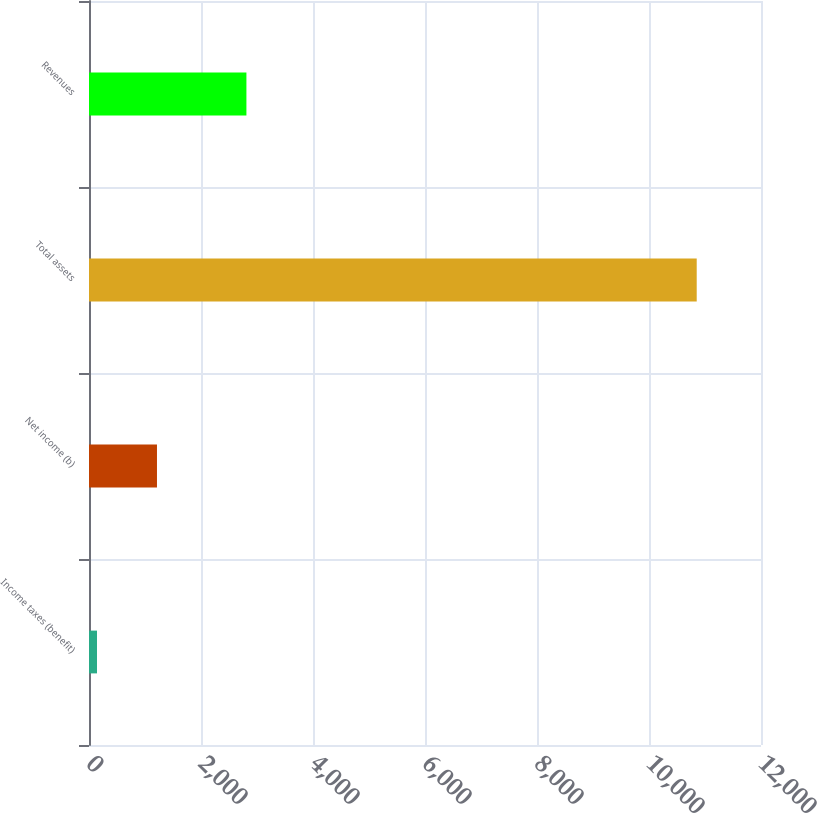Convert chart. <chart><loc_0><loc_0><loc_500><loc_500><bar_chart><fcel>Income taxes (benefit)<fcel>Net income (b)<fcel>Total assets<fcel>Revenues<nl><fcel>143<fcel>1213.9<fcel>10852<fcel>2811<nl></chart> 